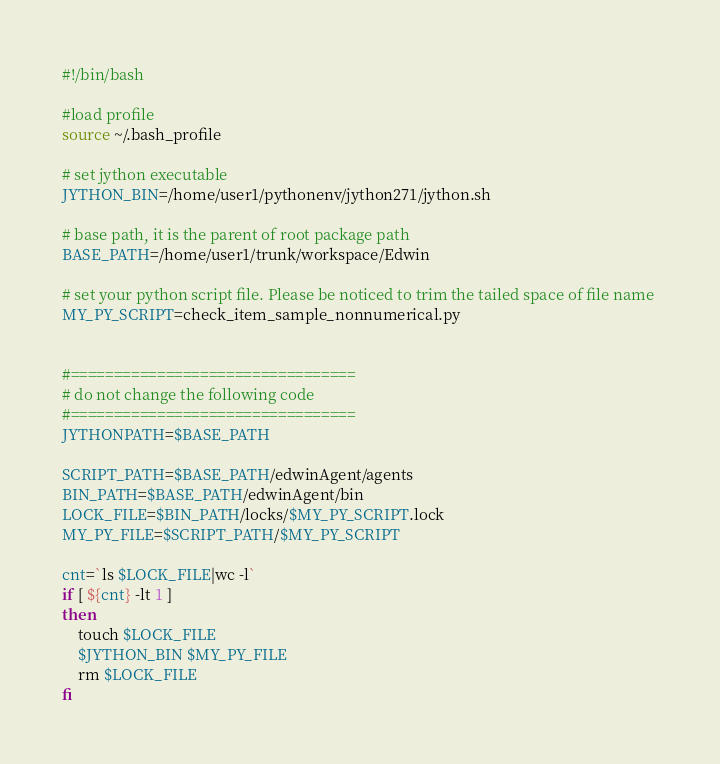Convert code to text. <code><loc_0><loc_0><loc_500><loc_500><_Bash_>#!/bin/bash

#load profile
source ~/.bash_profile

# set jython executable 
JYTHON_BIN=/home/user1/pythonenv/jython271/jython.sh

# base path, it is the parent of root package path 
BASE_PATH=/home/user1/trunk/workspace/Edwin

# set your python script file. Please be noticed to trim the tailed space of file name 
MY_PY_SCRIPT=check_item_sample_nonnumerical.py


#=================================
# do not change the following code
#=================================
JYTHONPATH=$BASE_PATH

SCRIPT_PATH=$BASE_PATH/edwinAgent/agents
BIN_PATH=$BASE_PATH/edwinAgent/bin
LOCK_FILE=$BIN_PATH/locks/$MY_PY_SCRIPT.lock
MY_PY_FILE=$SCRIPT_PATH/$MY_PY_SCRIPT

cnt=`ls $LOCK_FILE|wc -l`
if [ ${cnt} -lt 1 ]
then
    touch $LOCK_FILE
    $JYTHON_BIN $MY_PY_FILE
    rm $LOCK_FILE
fi

</code> 